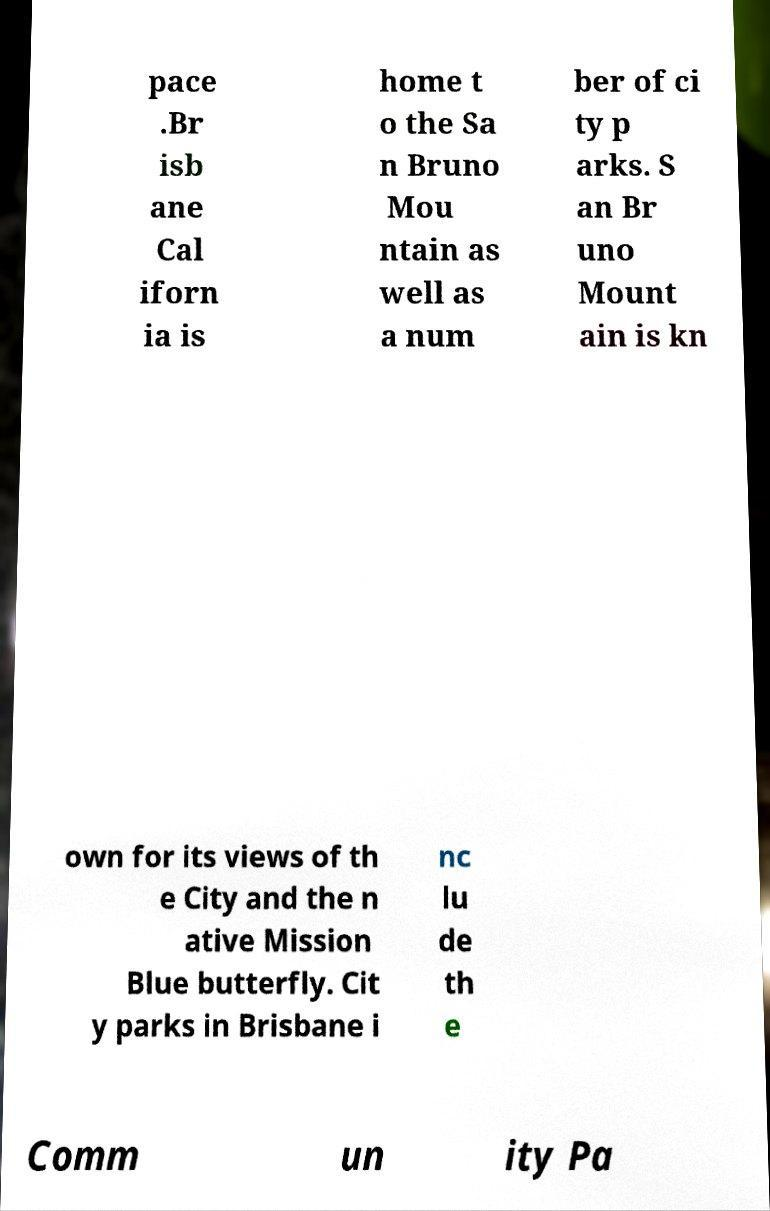I need the written content from this picture converted into text. Can you do that? pace .Br isb ane Cal iforn ia is home t o the Sa n Bruno Mou ntain as well as a num ber of ci ty p arks. S an Br uno Mount ain is kn own for its views of th e City and the n ative Mission Blue butterfly. Cit y parks in Brisbane i nc lu de th e Comm un ity Pa 